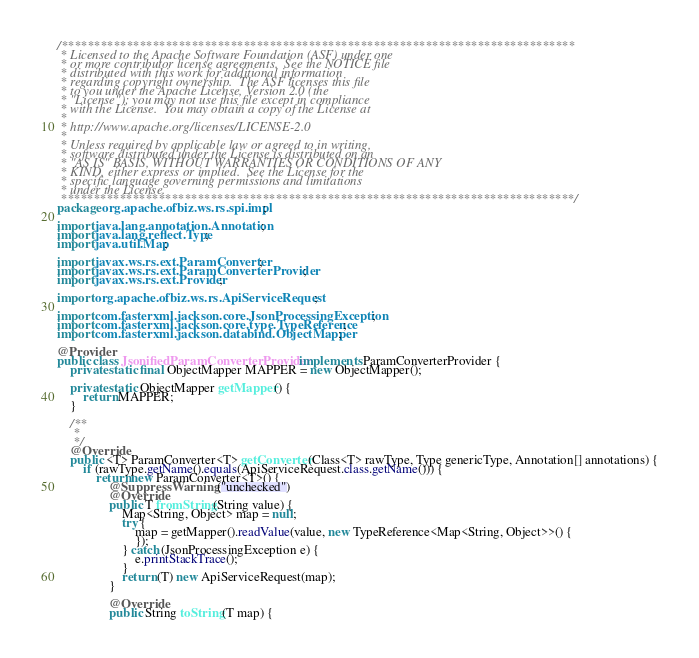Convert code to text. <code><loc_0><loc_0><loc_500><loc_500><_Java_>/*******************************************************************************
 * Licensed to the Apache Software Foundation (ASF) under one
 * or more contributor license agreements.  See the NOTICE file
 * distributed with this work for additional information
 * regarding copyright ownership.  The ASF licenses this file
 * to you under the Apache License, Version 2.0 (the
 * "License"); you may not use this file except in compliance
 * with the License.  You may obtain a copy of the License at
 *
 * http://www.apache.org/licenses/LICENSE-2.0
 *
 * Unless required by applicable law or agreed to in writing,
 * software distributed under the License is distributed on an
 * "AS IS" BASIS, WITHOUT WARRANTIES OR CONDITIONS OF ANY
 * KIND, either express or implied.  See the License for the
 * specific language governing permissions and limitations
 * under the License.
 *******************************************************************************/
package org.apache.ofbiz.ws.rs.spi.impl;

import java.lang.annotation.Annotation;
import java.lang.reflect.Type;
import java.util.Map;

import javax.ws.rs.ext.ParamConverter;
import javax.ws.rs.ext.ParamConverterProvider;
import javax.ws.rs.ext.Provider;

import org.apache.ofbiz.ws.rs.ApiServiceRequest;

import com.fasterxml.jackson.core.JsonProcessingException;
import com.fasterxml.jackson.core.type.TypeReference;
import com.fasterxml.jackson.databind.ObjectMapper;

@Provider
public class JsonifiedParamConverterProvider implements ParamConverterProvider {
    private static final ObjectMapper MAPPER = new ObjectMapper();

    private static ObjectMapper getMapper() {
        return MAPPER;
    }

    /**
     *
     */
    @Override
    public <T> ParamConverter<T> getConverter(Class<T> rawType, Type genericType, Annotation[] annotations) {
        if (rawType.getName().equals(ApiServiceRequest.class.getName())) {
            return new ParamConverter<T>() {
                @SuppressWarnings("unchecked")
                @Override
                public T fromString(String value) {
                    Map<String, Object> map = null;
                    try {
                        map = getMapper().readValue(value, new TypeReference<Map<String, Object>>() {
                        });
                    } catch (JsonProcessingException e) {
                        e.printStackTrace();
                    }
                    return (T) new ApiServiceRequest(map);
                }

                @Override
                public String toString(T map) {</code> 